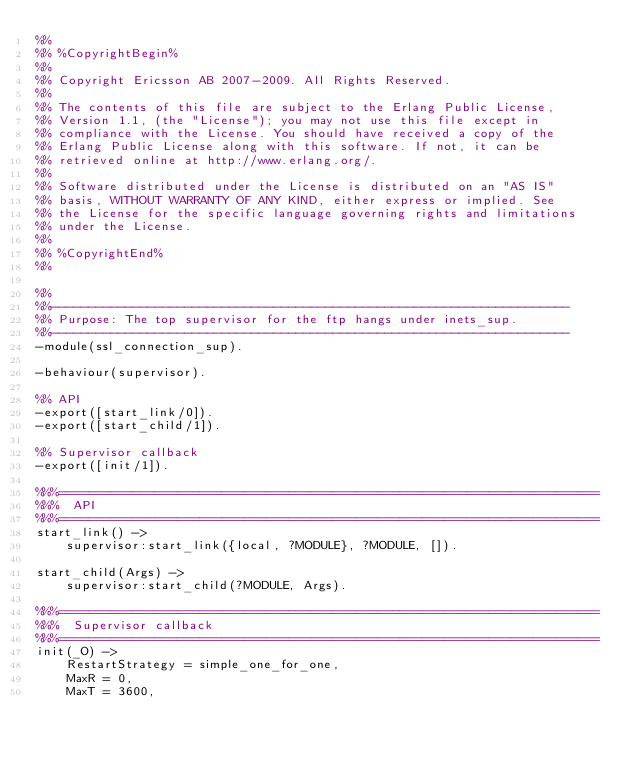Convert code to text. <code><loc_0><loc_0><loc_500><loc_500><_Erlang_>%%
%% %CopyrightBegin%
%% 
%% Copyright Ericsson AB 2007-2009. All Rights Reserved.
%% 
%% The contents of this file are subject to the Erlang Public License,
%% Version 1.1, (the "License"); you may not use this file except in
%% compliance with the License. You should have received a copy of the
%% Erlang Public License along with this software. If not, it can be
%% retrieved online at http://www.erlang.org/.
%% 
%% Software distributed under the License is distributed on an "AS IS"
%% basis, WITHOUT WARRANTY OF ANY KIND, either express or implied. See
%% the License for the specific language governing rights and limitations
%% under the License.
%% 
%% %CopyrightEnd%
%%

%%
%%----------------------------------------------------------------------
%% Purpose: The top supervisor for the ftp hangs under inets_sup.
%%----------------------------------------------------------------------
-module(ssl_connection_sup).

-behaviour(supervisor).

%% API
-export([start_link/0]).
-export([start_child/1]).

%% Supervisor callback
-export([init/1]).

%%%=========================================================================
%%%  API
%%%=========================================================================
start_link() ->
    supervisor:start_link({local, ?MODULE}, ?MODULE, []).

start_child(Args) ->
    supervisor:start_child(?MODULE, Args).
    
%%%=========================================================================
%%%  Supervisor callback
%%%=========================================================================
init(_O) ->
    RestartStrategy = simple_one_for_one,
    MaxR = 0,
    MaxT = 3600,
   </code> 